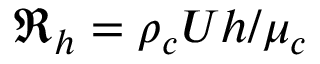Convert formula to latex. <formula><loc_0><loc_0><loc_500><loc_500>\Re _ { h } = \rho _ { c } U h / \mu _ { c }</formula> 